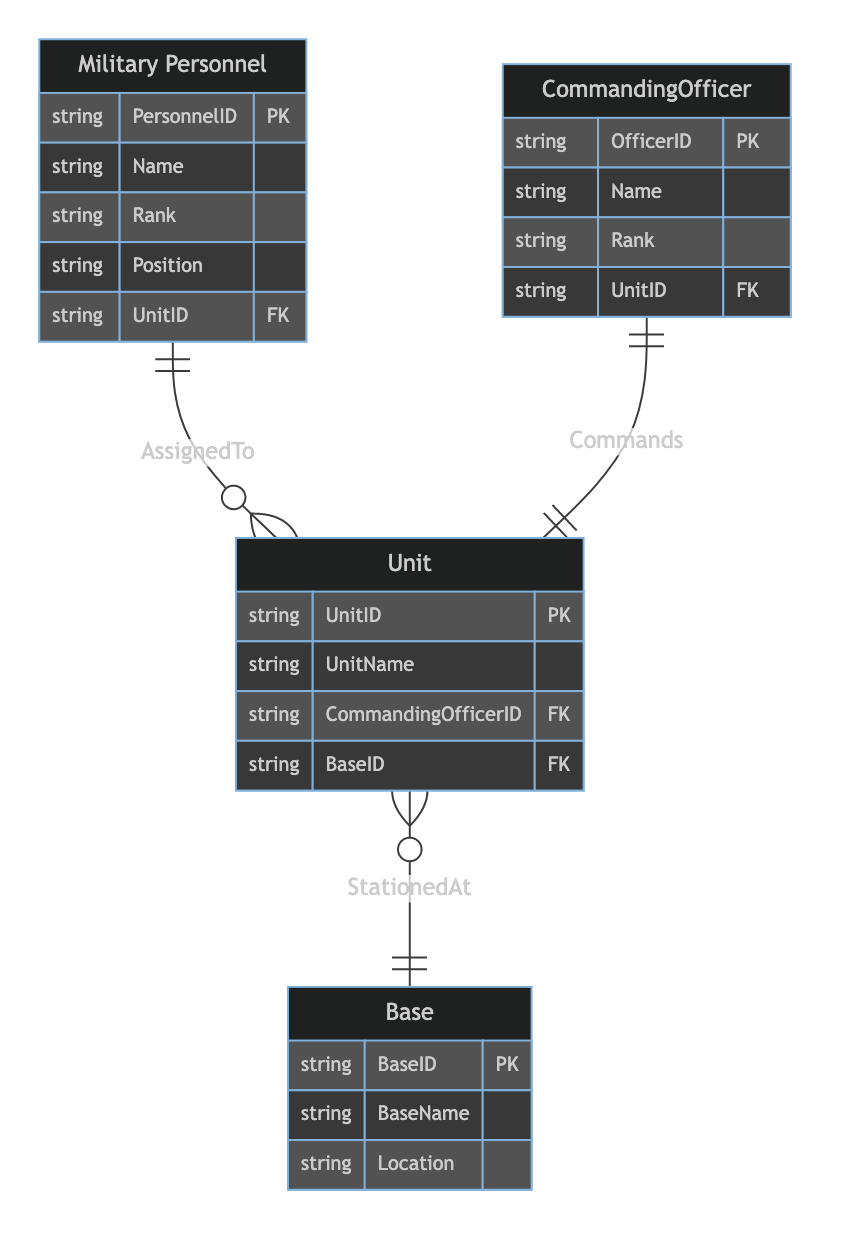What is the primary key of the Military Personnel entity? The primary key is indicated by the "PK" notation in the attributes of the entity. In the Military Personnel entity, the PersonnelID is marked as the primary key (PK).
Answer: PersonnelID How many entities are present in the diagram? The diagram outlines four distinct entities: Military Personnel, Unit, Commanding Officer, and Base. Counting each gives a total of four entities.
Answer: 4 What relationship exists between Unit and Base? The relationship "StationedAt" is specified between Unit and Base in the relationships section of the diagram, indicating that Units are stationed at Bases.
Answer: StationedAt Which entity has the attribute CommandingOfficerID? The CommandingOfficerID attribute is found in the Unit entity, where it indicates the officer in command of the unit.
Answer: Unit What is the total number of relationships defined in the diagram? The diagram specifies three relationships: AssignedTo, Commands, and StationedAt. Counting these gives a total of three relationships present in the diagram.
Answer: 3 Who commands a Unit? The diagram indicates that a Commanding Officer commands a Unit based on the "Commands" relationship outlined between these two entities.
Answer: Commanding Officer Which attribute connects Military Personnel to Unit? The connection between Military Personnel and Unit is made through the UnitID attribute in the Military Personnel entity, which acts as a foreign key (FK).
Answer: UnitID What is the location attribute for Base? The Base entity includes the Location attribute, which specifies where the base is situated.
Answer: Location 